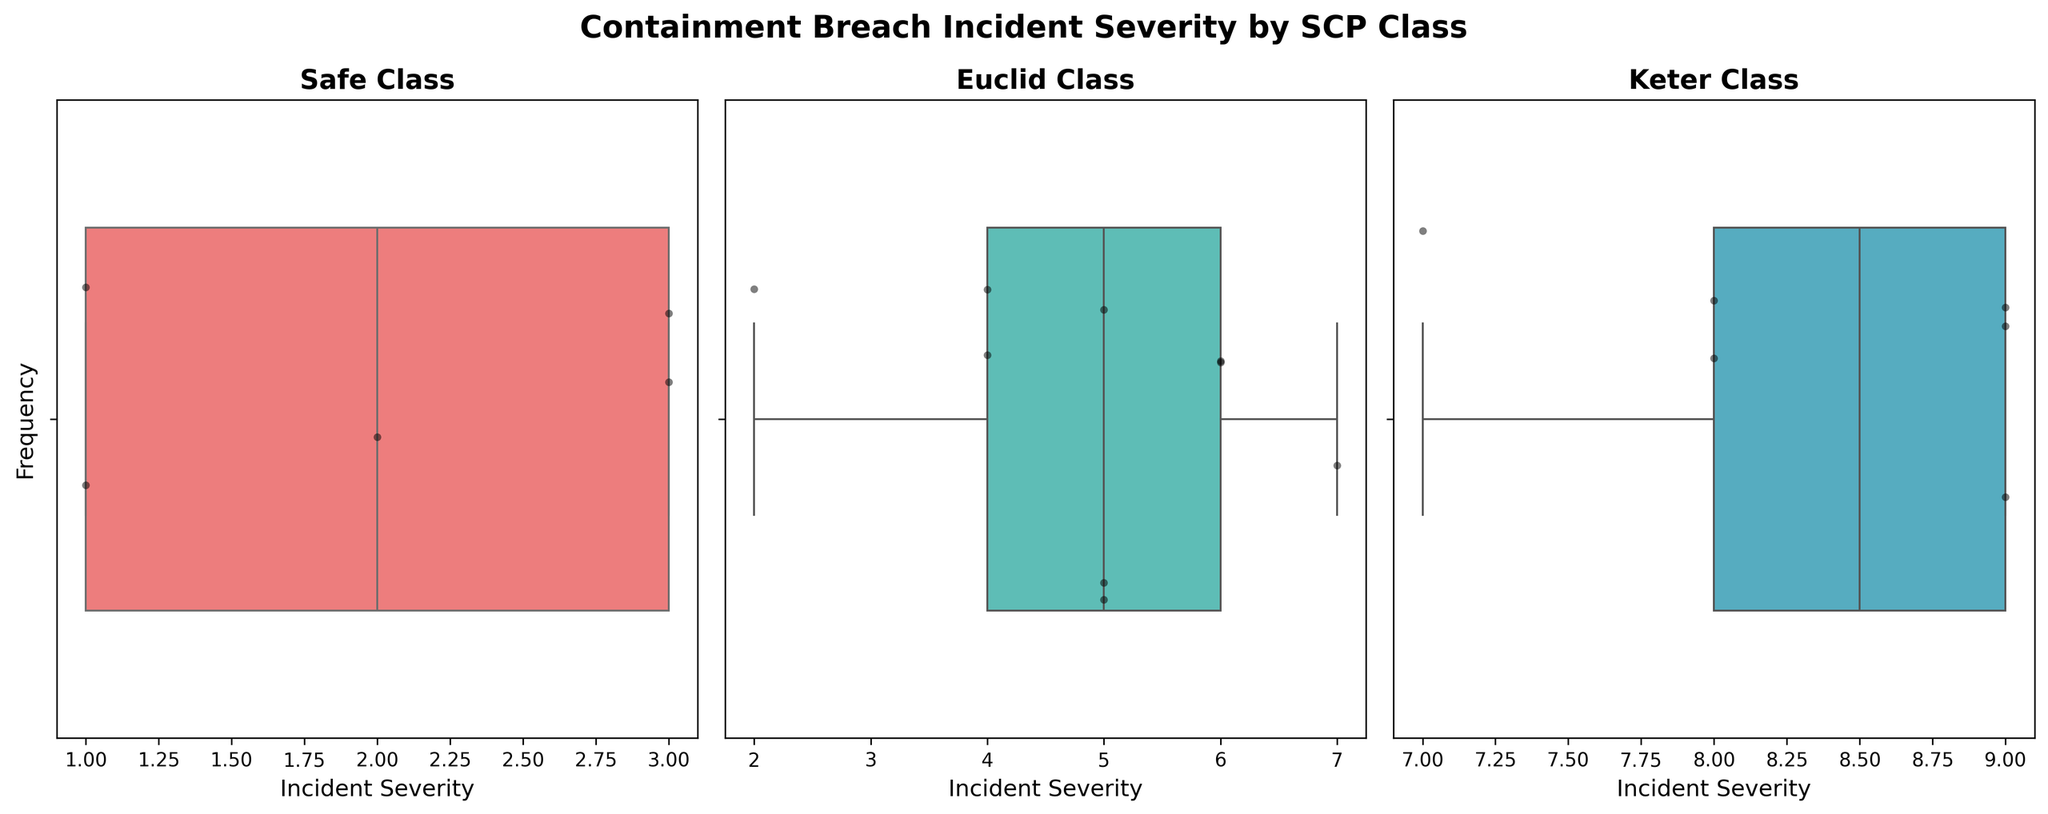What is the title of the figure? The title is usually displayed prominently at the top or center of the figure. In this case, the title is written clearly in bold text above the subplots.
Answer: Containment Breach Incident Severity by SCP Class What are the three SCP classes shown in the subplots? The titles of the subplots, written above each box plot, clearly indicate the SCP classes being analyzed.
Answer: Safe, Euclid, Keter Which SCP class has the highest median incident severity? In a box plot, the median is represented by the line inside the box. By comparing the lines across the three subplots, we see that the Keter class has the highest median.
Answer: Keter What is the range of incident severity in the Safe class? The range can be identified by noting the minimum and maximum values of the box plot whiskers. For the Safe class, the lowest value is 1 and the highest value is 3.
Answer: 1 to 3 How many unique data points are in the Keter class? The individual points superimposed on the box plot through the strip plot represent each incident. Counting these points within the Keter class subplot gives the number of unique data points.
Answer: 5 Which SCP class shows the smallest variability in incident severities? Variability can be inferred by the length of the boxes and whiskers. The shorter the range, the smaller the variability. The Safe class has the smallest range, indicating the least variability.
Answer: Safe Between which classes is the difference in median incident severity the greatest? By comparing the median lines of the box plots, the difference between Safe (median around 2) and Keter (median around 8.5) is the greatest. This difference is 8.5 - 2 = 6.5.
Answer: Safe and Keter What is the most frequent incident severity for Euclid class? The strip plot shows the distribution of values clearly, with the density of points indicating frequency. For Euclid, the severity of 5 appears most frequently.
Answer: 5 How does the incident severity of the Safe class compare to the Euclid class? Comparing the medians and ranges of the box plots, the Safe class has lower median and range compared to the Euclid class.
Answer: Lower Which subclass depicts a more consistent severity pattern, Safe or Keter? Consistency can be seen through smaller ranges and less spread in points. The Safe class box plot shows a more consistent severity pattern with less variability compared to the Keter class.
Answer: Safe 